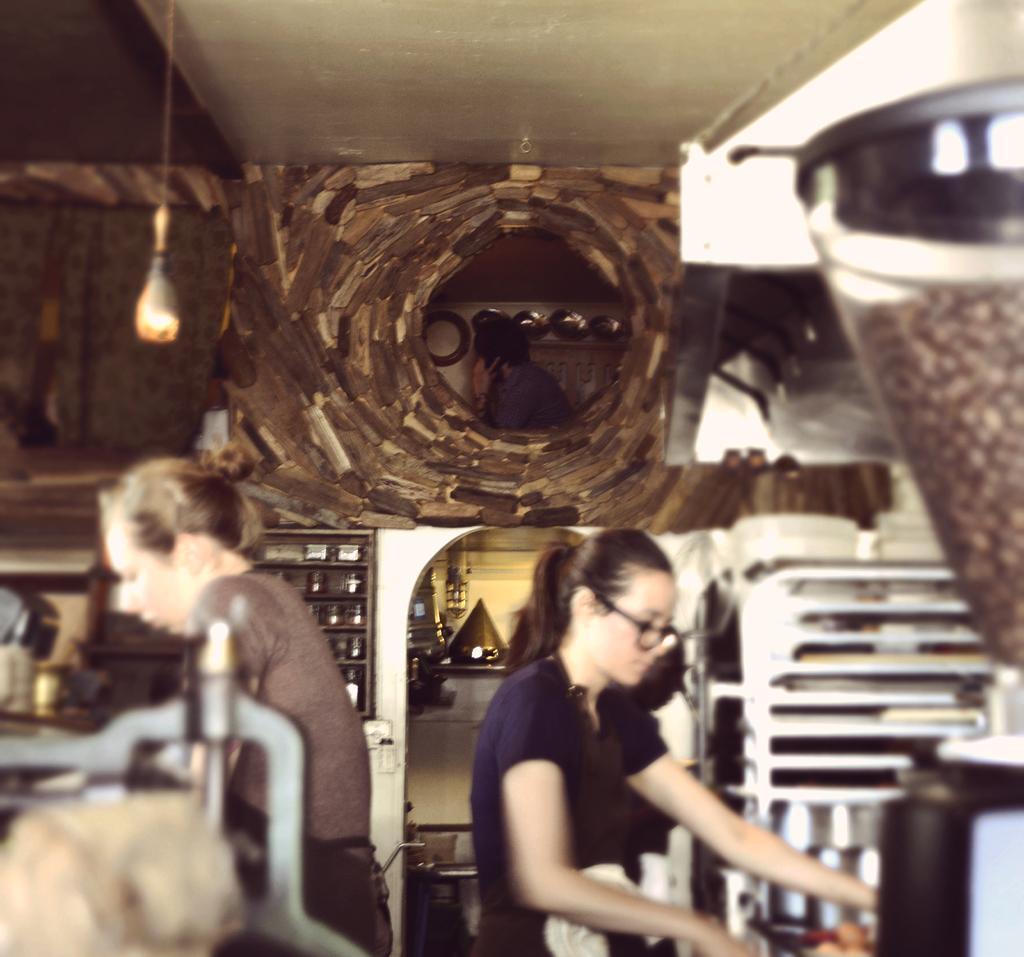Could you give a brief overview of what you see in this image? In this image, there is an inside view of a room. There are two persons at the bottom of the image standing and wearing clothes. There is a light in the top left of the image. There is a coffee machine on the right side of the image. 